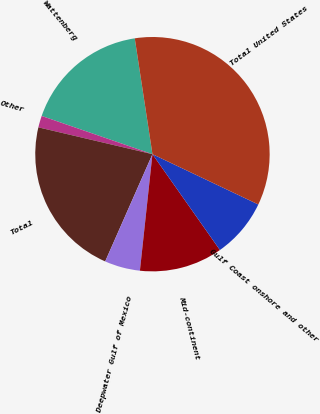<chart> <loc_0><loc_0><loc_500><loc_500><pie_chart><fcel>Wattenberg<fcel>Other<fcel>Total<fcel>Deepwater Gulf of Mexico<fcel>Mid-continent<fcel>Gulf Coast onshore and other<fcel>Total United States<nl><fcel>17.3%<fcel>1.61%<fcel>22.07%<fcel>4.9%<fcel>11.47%<fcel>8.18%<fcel>34.47%<nl></chart> 